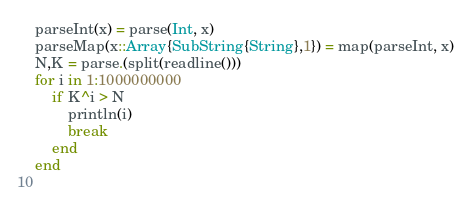<code> <loc_0><loc_0><loc_500><loc_500><_Julia_>parseInt(x) = parse(Int, x)
parseMap(x::Array{SubString{String},1}) = map(parseInt, x)
N,K = parse.(split(readline()))
for i in 1:1000000000
    if K^i > N
        println(i)
        break
    end
end    
    </code> 